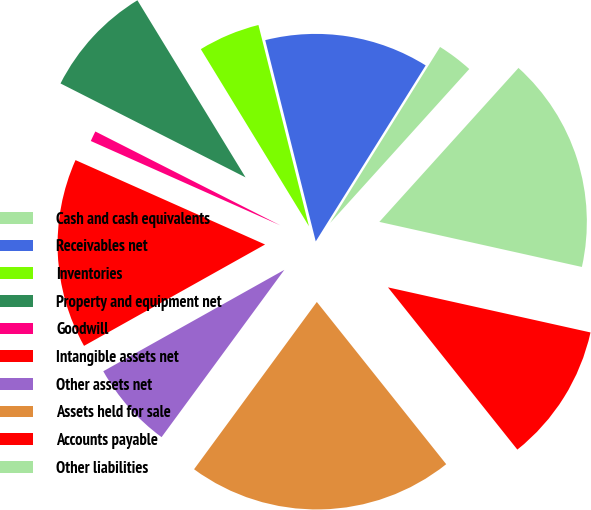Convert chart to OTSL. <chart><loc_0><loc_0><loc_500><loc_500><pie_chart><fcel>Cash and cash equivalents<fcel>Receivables net<fcel>Inventories<fcel>Property and equipment net<fcel>Goodwill<fcel>Intangible assets net<fcel>Other assets net<fcel>Assets held for sale<fcel>Accounts payable<fcel>Other liabilities<nl><fcel>2.81%<fcel>12.8%<fcel>4.81%<fcel>8.8%<fcel>0.81%<fcel>14.79%<fcel>6.8%<fcel>20.79%<fcel>10.8%<fcel>16.79%<nl></chart> 